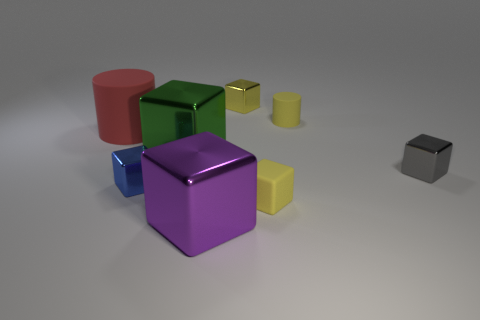Subtract all yellow blocks. How many blocks are left? 4 Subtract all small gray shiny blocks. How many blocks are left? 5 Subtract all purple cubes. Subtract all blue spheres. How many cubes are left? 5 Add 1 large purple shiny cubes. How many objects exist? 9 Subtract all cylinders. How many objects are left? 6 Subtract all small yellow objects. Subtract all small cylinders. How many objects are left? 4 Add 8 gray blocks. How many gray blocks are left? 9 Add 1 tiny shiny objects. How many tiny shiny objects exist? 4 Subtract 0 brown cylinders. How many objects are left? 8 